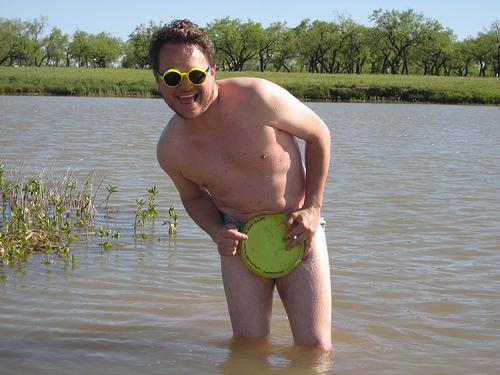What is this man holding?
Answer briefly. Frisbee. Where does the come up to on this man's body?
Be succinct. Knees. Is the man shirtless?
Quick response, please. Yes. 